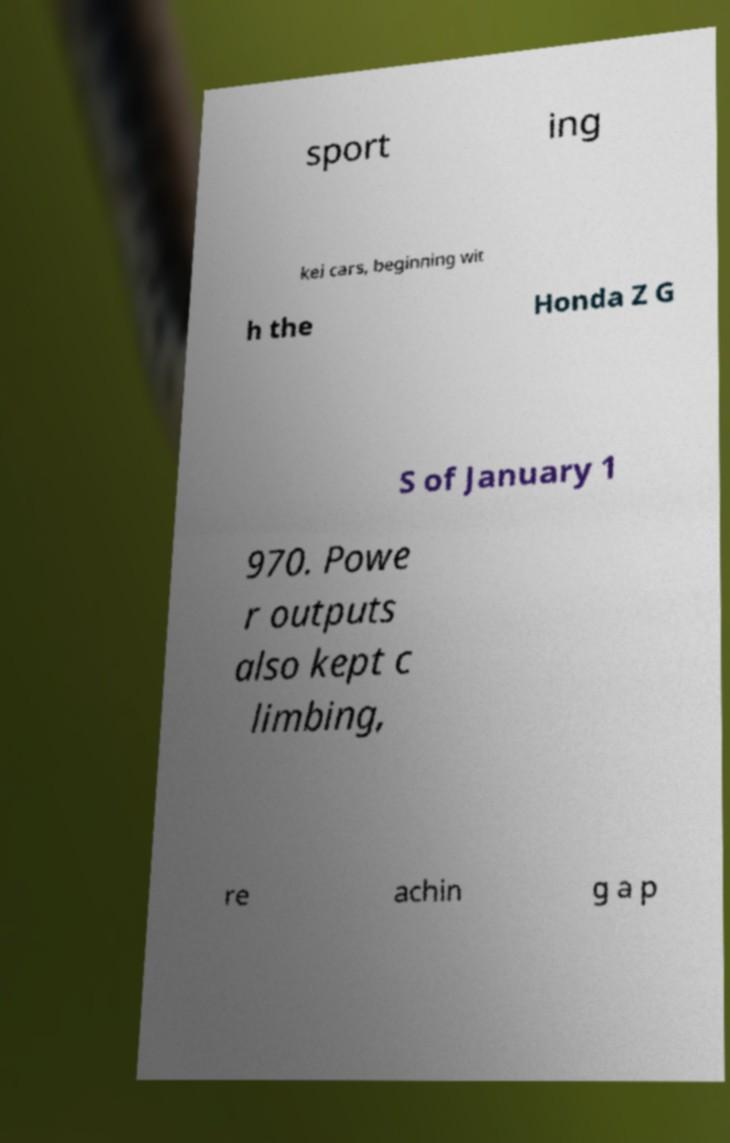For documentation purposes, I need the text within this image transcribed. Could you provide that? sport ing kei cars, beginning wit h the Honda Z G S of January 1 970. Powe r outputs also kept c limbing, re achin g a p 